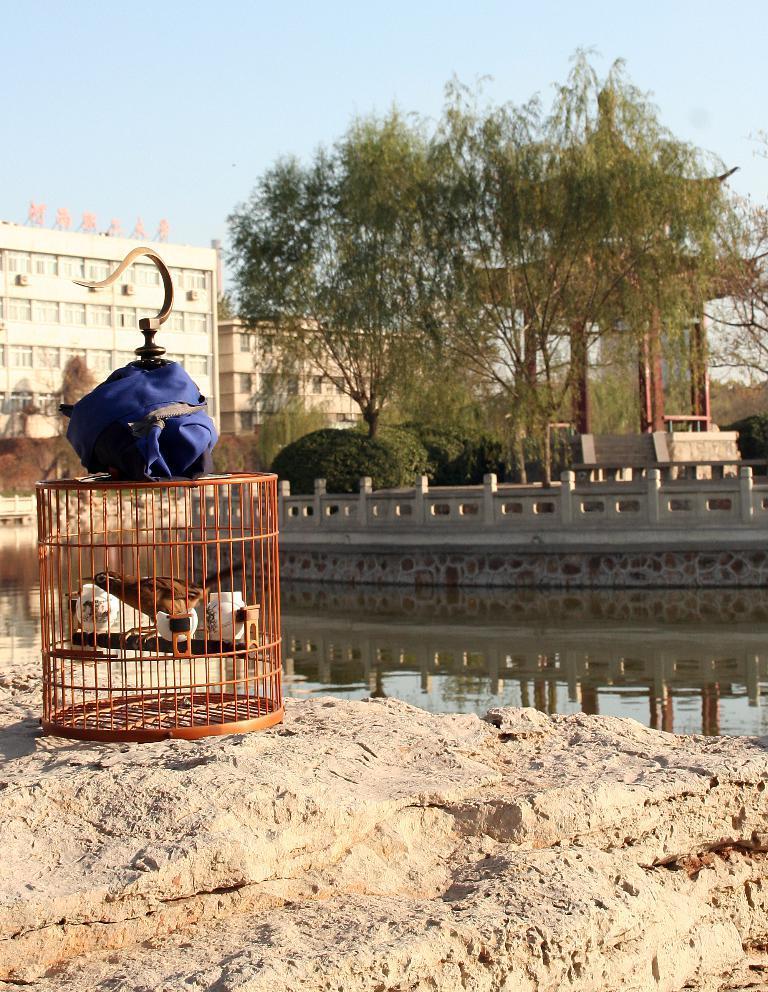Describe this image in one or two sentences. In this image there are birds in a cage, the cage is on the rock, on the other side of the rock there is water, on the other side of the water, there is a concrete fence, on the other side of the fence there are trees and buildings. 